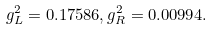Convert formula to latex. <formula><loc_0><loc_0><loc_500><loc_500>g _ { L } ^ { 2 } = 0 . 1 7 5 8 6 , g _ { R } ^ { 2 } = 0 . 0 0 9 9 4 .</formula> 